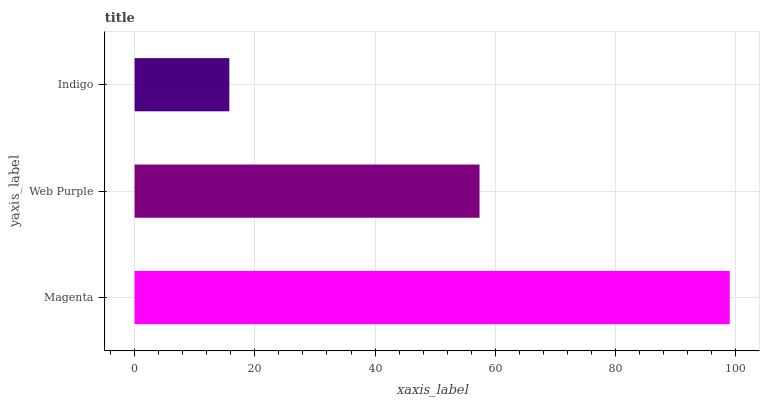Is Indigo the minimum?
Answer yes or no. Yes. Is Magenta the maximum?
Answer yes or no. Yes. Is Web Purple the minimum?
Answer yes or no. No. Is Web Purple the maximum?
Answer yes or no. No. Is Magenta greater than Web Purple?
Answer yes or no. Yes. Is Web Purple less than Magenta?
Answer yes or no. Yes. Is Web Purple greater than Magenta?
Answer yes or no. No. Is Magenta less than Web Purple?
Answer yes or no. No. Is Web Purple the high median?
Answer yes or no. Yes. Is Web Purple the low median?
Answer yes or no. Yes. Is Indigo the high median?
Answer yes or no. No. Is Magenta the low median?
Answer yes or no. No. 